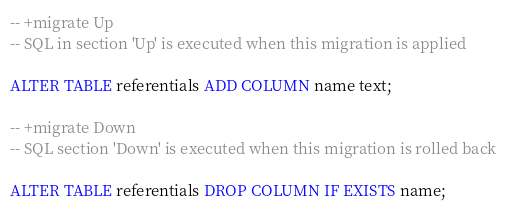Convert code to text. <code><loc_0><loc_0><loc_500><loc_500><_SQL_>-- +migrate Up
-- SQL in section 'Up' is executed when this migration is applied

ALTER TABLE referentials ADD COLUMN name text;

-- +migrate Down
-- SQL section 'Down' is executed when this migration is rolled back

ALTER TABLE referentials DROP COLUMN IF EXISTS name;</code> 